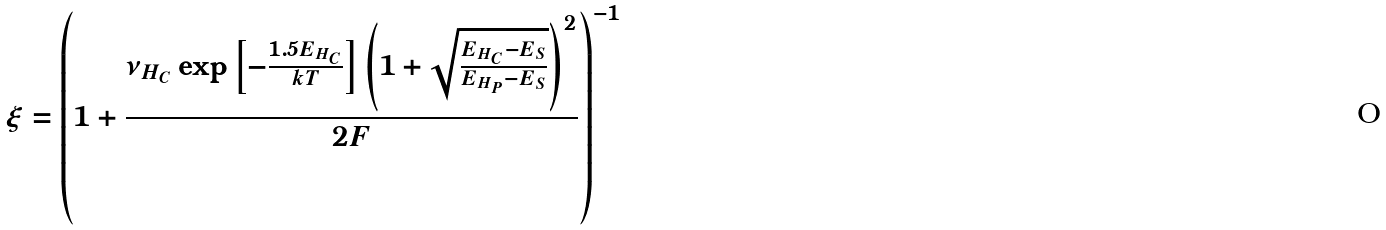Convert formula to latex. <formula><loc_0><loc_0><loc_500><loc_500>\xi = \left ( { 1 + \frac { \nu _ { H _ { C } } \exp \left [ - \frac { 1 . 5 E _ { H _ { C } } } { k T } \right ] \left ( 1 + \sqrt { \frac { E _ { H _ { C } } - E _ { S } } { E _ { H _ { P } } - E _ { S } } } \right ) ^ { 2 } } { 2 F } } \right ) ^ { - 1 }</formula> 